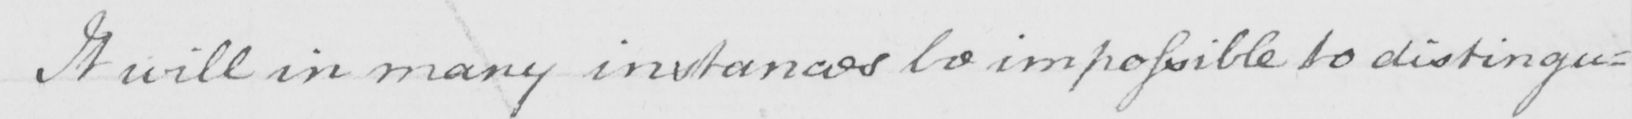What is written in this line of handwriting? It will in many instances be impossible to distingu= 